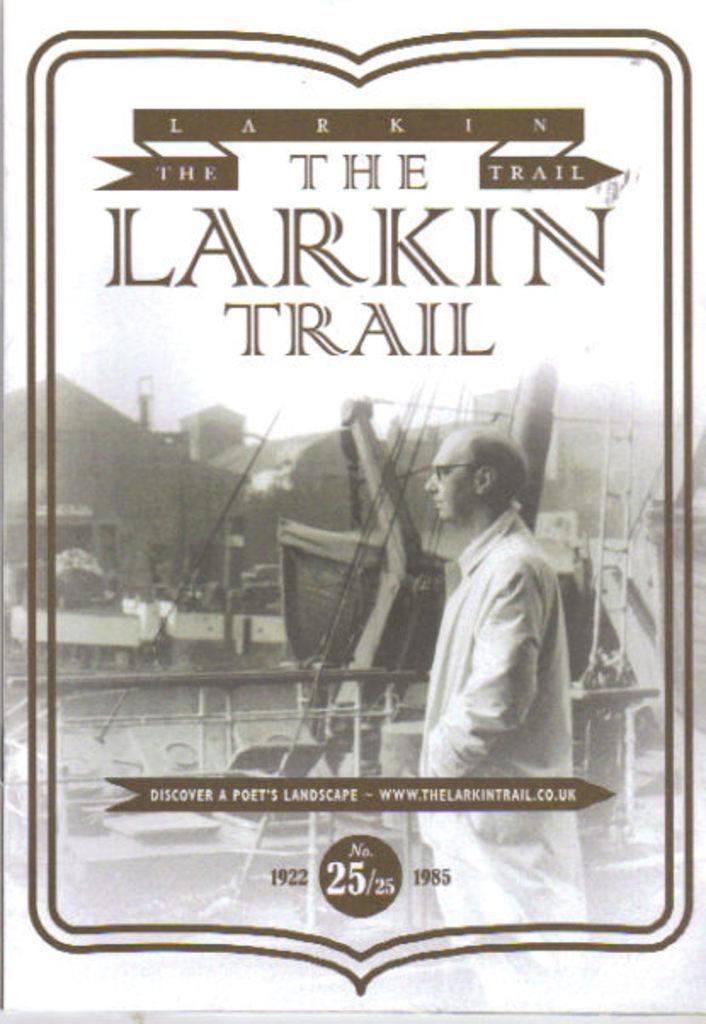Who is depicted in the poster? There is a man in the poster. What is the man wearing in the poster? The man is wearing spectacles in the poster. What is the man's posture in the poster? The man is standing in the poster. What can be seen in the background of the poster? There is a fence and buildings in the poster. Is there any text on the poster? Yes, there is text on the poster. What type of car is the man driving in the poster? There is no car present in the poster; it features a man standing with spectacles, a fence, buildings, and text. What appliance is the man using his hands in the poster? The poster does not depict the man using any appliance with his hands; he is simply standing with spectacles. 